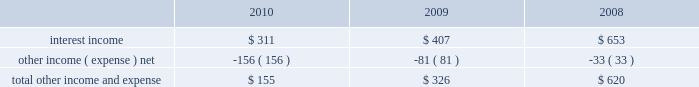Table of contents research and development expense ( 201cr&d 201d ) r&d expense increased 34% ( 34 % ) or $ 449 million to $ 1.8 billion in 2010 compared to 2009 .
This increase was due primarily to an increase in headcount and related expenses in the current year to support expanded r&d activities .
Also contributing to this increase in r&d expense in 2010 was the capitalization in 2009 of software development costs of $ 71 million related to mac os x snow leopard .
Although total r&d expense increased 34% ( 34 % ) during 2010 , it declined as a percentage of net sales given the 52% ( 52 % ) year-over-year increase in net sales in 2010 .
The company continues to believe that focused investments in r&d are critical to its future growth and competitive position in the marketplace and are directly related to timely development of new and enhanced products that are central to the company 2019s core business strategy .
As such , the company expects to make further investments in r&d to remain competitive .
R&d expense increased 20% ( 20 % ) or $ 224 million to $ 1.3 billion in 2009 compared to 2008 .
This increase was due primarily to an increase in headcount in 2009 to support expanded r&d activities and higher stock-based compensation expenses .
Additionally , $ 71 million of software development costs were capitalized related to mac os x snow leopard and excluded from r&d expense during 2009 , compared to $ 11 million of software development costs capitalized during 2008 .
Although total r&d expense increased 20% ( 20 % ) during 2009 , it remained relatively flat as a percentage of net sales given the 14% ( 14 % ) increase in revenue in 2009 .
Selling , general and administrative expense ( 201csg&a 201d ) sg&a expense increased $ 1.4 billion or 33% ( 33 % ) to $ 5.5 billion in 2010 compared to 2009 .
This increase was due primarily to the company 2019s continued expansion of its retail segment , higher spending on marketing and advertising programs , increased stock-based compensation expenses and variable costs associated with the overall growth of the company 2019s net sales .
Sg&a expenses increased $ 388 million or 10% ( 10 % ) to $ 4.1 billion in 2009 compared to 2008 .
This increase was due primarily to the company 2019s continued expansion of its retail segment in both domestic and international markets , higher stock-based compensation expense and higher spending on marketing and advertising .
Other income and expense other income and expense for the three years ended september 25 , 2010 , are as follows ( in millions ) : total other income and expense decreased $ 171 million or 52% ( 52 % ) to $ 155 million during 2010 compared to $ 326 million and $ 620 million in 2009 and 2008 , respectively .
The overall decrease in other income and expense is attributable to the significant declines in interest rates on a year- over-year basis , partially offset by the company 2019s higher cash , cash equivalents and marketable securities balances .
The weighted average interest rate earned by the company on its cash , cash equivalents and marketable securities was 0.75% ( 0.75 % ) , 1.43% ( 1.43 % ) and 3.44% ( 3.44 % ) during 2010 , 2009 and 2008 , respectively .
Additionally the company incurred higher premium expenses on its foreign exchange option contracts , which further reduced the total other income and expense .
During 2010 , 2009 and 2008 , the company had no debt outstanding and accordingly did not incur any related interest expense .
Provision for income taxes the company 2019s effective tax rates were 24% ( 24 % ) , 32% ( 32 % ) and 32% ( 32 % ) for 2010 , 2009 and 2008 , respectively .
The company 2019s effective rates for these periods differ from the statutory federal income tax rate of 35% ( 35 % ) due .

What was the average effective tax rates for 2010 , 2009 and 2008? 
Computations: (((24 + 32) + 32) / 3)
Answer: 29.33333. Table of contents research and development expense ( 201cr&d 201d ) r&d expense increased 34% ( 34 % ) or $ 449 million to $ 1.8 billion in 2010 compared to 2009 .
This increase was due primarily to an increase in headcount and related expenses in the current year to support expanded r&d activities .
Also contributing to this increase in r&d expense in 2010 was the capitalization in 2009 of software development costs of $ 71 million related to mac os x snow leopard .
Although total r&d expense increased 34% ( 34 % ) during 2010 , it declined as a percentage of net sales given the 52% ( 52 % ) year-over-year increase in net sales in 2010 .
The company continues to believe that focused investments in r&d are critical to its future growth and competitive position in the marketplace and are directly related to timely development of new and enhanced products that are central to the company 2019s core business strategy .
As such , the company expects to make further investments in r&d to remain competitive .
R&d expense increased 20% ( 20 % ) or $ 224 million to $ 1.3 billion in 2009 compared to 2008 .
This increase was due primarily to an increase in headcount in 2009 to support expanded r&d activities and higher stock-based compensation expenses .
Additionally , $ 71 million of software development costs were capitalized related to mac os x snow leopard and excluded from r&d expense during 2009 , compared to $ 11 million of software development costs capitalized during 2008 .
Although total r&d expense increased 20% ( 20 % ) during 2009 , it remained relatively flat as a percentage of net sales given the 14% ( 14 % ) increase in revenue in 2009 .
Selling , general and administrative expense ( 201csg&a 201d ) sg&a expense increased $ 1.4 billion or 33% ( 33 % ) to $ 5.5 billion in 2010 compared to 2009 .
This increase was due primarily to the company 2019s continued expansion of its retail segment , higher spending on marketing and advertising programs , increased stock-based compensation expenses and variable costs associated with the overall growth of the company 2019s net sales .
Sg&a expenses increased $ 388 million or 10% ( 10 % ) to $ 4.1 billion in 2009 compared to 2008 .
This increase was due primarily to the company 2019s continued expansion of its retail segment in both domestic and international markets , higher stock-based compensation expense and higher spending on marketing and advertising .
Other income and expense other income and expense for the three years ended september 25 , 2010 , are as follows ( in millions ) : total other income and expense decreased $ 171 million or 52% ( 52 % ) to $ 155 million during 2010 compared to $ 326 million and $ 620 million in 2009 and 2008 , respectively .
The overall decrease in other income and expense is attributable to the significant declines in interest rates on a year- over-year basis , partially offset by the company 2019s higher cash , cash equivalents and marketable securities balances .
The weighted average interest rate earned by the company on its cash , cash equivalents and marketable securities was 0.75% ( 0.75 % ) , 1.43% ( 1.43 % ) and 3.44% ( 3.44 % ) during 2010 , 2009 and 2008 , respectively .
Additionally the company incurred higher premium expenses on its foreign exchange option contracts , which further reduced the total other income and expense .
During 2010 , 2009 and 2008 , the company had no debt outstanding and accordingly did not incur any related interest expense .
Provision for income taxes the company 2019s effective tax rates were 24% ( 24 % ) , 32% ( 32 % ) and 32% ( 32 % ) for 2010 , 2009 and 2008 , respectively .
The company 2019s effective rates for these periods differ from the statutory federal income tax rate of 35% ( 35 % ) due .

By how much did total other income and expense decrease from 2009 to 2010? 
Computations: ((326 - 155) / 326)
Answer: 0.52454. 